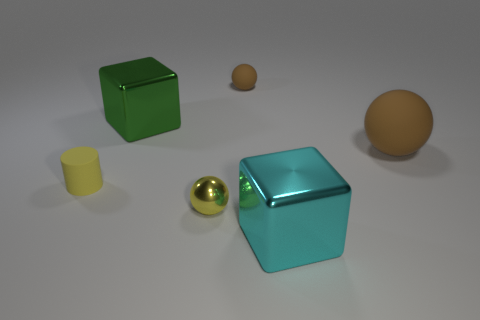How many other tiny brown things are the same shape as the small shiny object?
Provide a succinct answer. 1. What is the material of the cylinder?
Offer a terse response. Rubber. Do the big brown rubber thing and the large green thing have the same shape?
Your answer should be very brief. No. Are there any small brown cubes made of the same material as the big green block?
Provide a short and direct response. No. What color is the big object that is both on the left side of the big matte thing and in front of the green block?
Make the answer very short. Cyan. There is a large block that is behind the matte cylinder; what material is it?
Make the answer very short. Metal. Is there a big cyan thing of the same shape as the tiny shiny thing?
Provide a succinct answer. No. What number of other objects are the same shape as the big green shiny object?
Keep it short and to the point. 1. Do the tiny yellow metallic thing and the yellow thing on the left side of the metal ball have the same shape?
Offer a very short reply. No. Is there any other thing that is the same material as the big cyan thing?
Offer a terse response. Yes. 